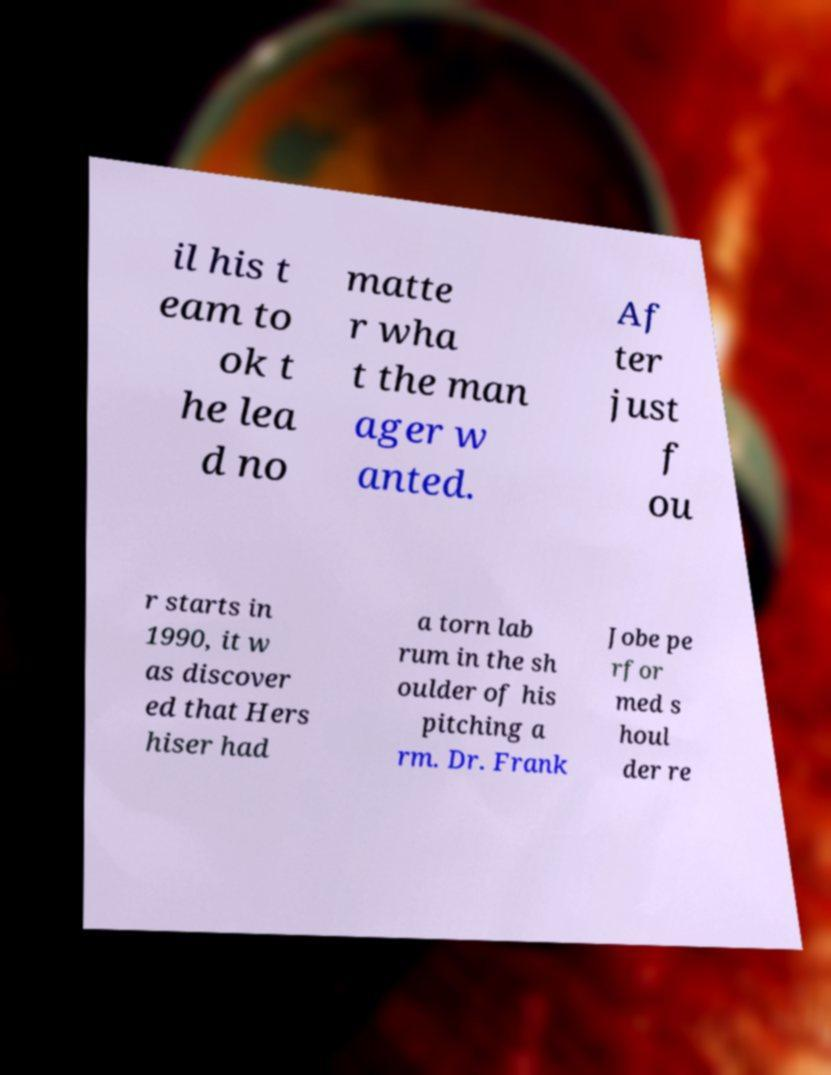Can you accurately transcribe the text from the provided image for me? il his t eam to ok t he lea d no matte r wha t the man ager w anted. Af ter just f ou r starts in 1990, it w as discover ed that Hers hiser had a torn lab rum in the sh oulder of his pitching a rm. Dr. Frank Jobe pe rfor med s houl der re 